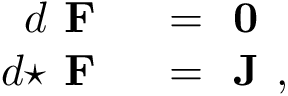Convert formula to latex. <formula><loc_0><loc_0><loc_500><loc_500>\begin{array} { r l } { d { F } } & = { 0 } } \\ { d { ^ { * } { F } } } & = { J } , } \end{array}</formula> 